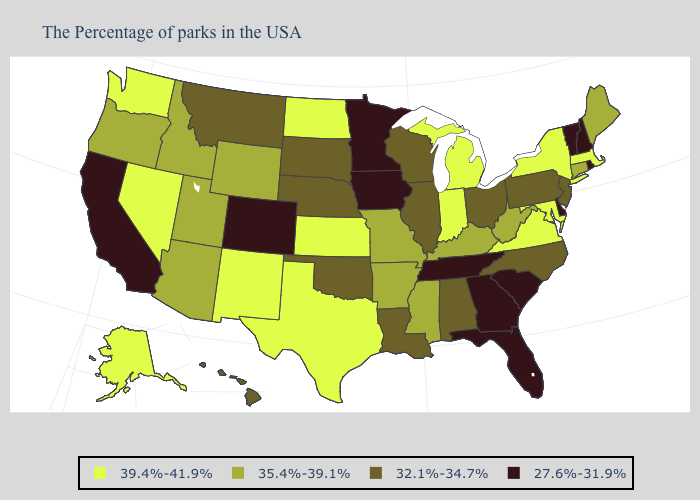Name the states that have a value in the range 27.6%-31.9%?
Concise answer only. Rhode Island, New Hampshire, Vermont, Delaware, South Carolina, Florida, Georgia, Tennessee, Minnesota, Iowa, Colorado, California. What is the highest value in the West ?
Write a very short answer. 39.4%-41.9%. Name the states that have a value in the range 27.6%-31.9%?
Keep it brief. Rhode Island, New Hampshire, Vermont, Delaware, South Carolina, Florida, Georgia, Tennessee, Minnesota, Iowa, Colorado, California. Does Texas have the highest value in the South?
Be succinct. Yes. Which states have the lowest value in the USA?
Answer briefly. Rhode Island, New Hampshire, Vermont, Delaware, South Carolina, Florida, Georgia, Tennessee, Minnesota, Iowa, Colorado, California. What is the value of Illinois?
Keep it brief. 32.1%-34.7%. What is the value of New Mexico?
Answer briefly. 39.4%-41.9%. Does the first symbol in the legend represent the smallest category?
Be succinct. No. Does Missouri have a higher value than Connecticut?
Keep it brief. No. What is the lowest value in the USA?
Keep it brief. 27.6%-31.9%. What is the value of Hawaii?
Short answer required. 32.1%-34.7%. Which states have the lowest value in the Northeast?
Keep it brief. Rhode Island, New Hampshire, Vermont. Is the legend a continuous bar?
Concise answer only. No. What is the value of Wisconsin?
Keep it brief. 32.1%-34.7%. What is the lowest value in the USA?
Quick response, please. 27.6%-31.9%. 